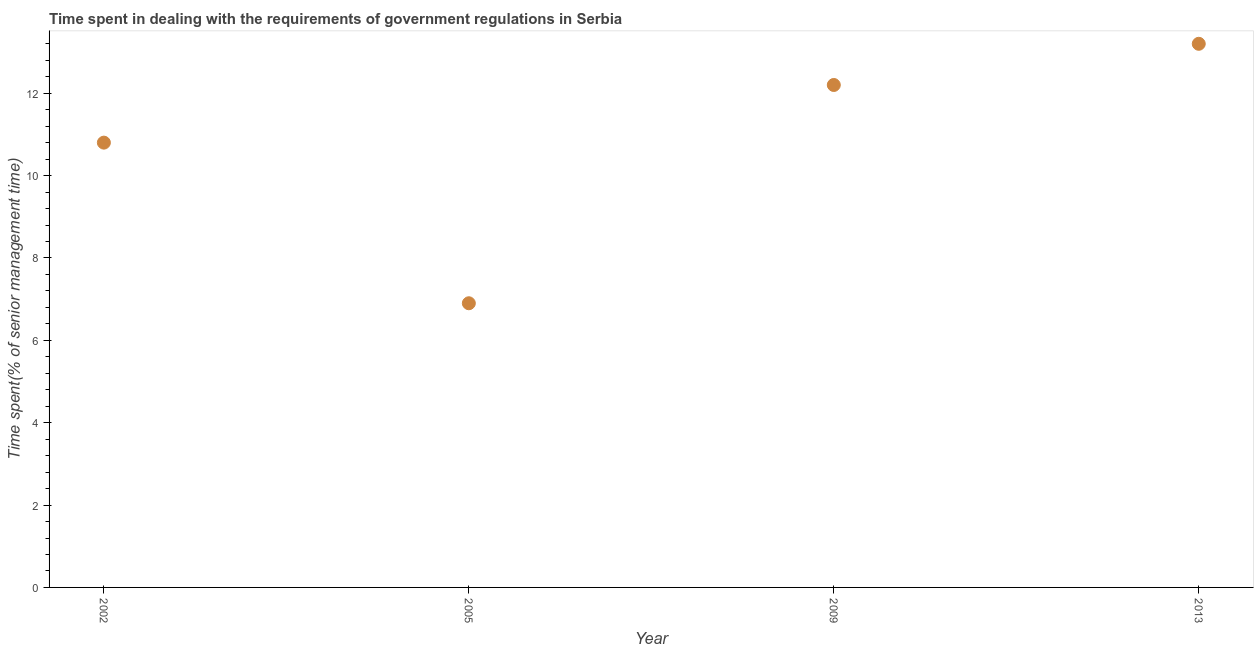What is the time spent in dealing with government regulations in 2005?
Provide a succinct answer. 6.9. Across all years, what is the maximum time spent in dealing with government regulations?
Your answer should be compact. 13.2. Across all years, what is the minimum time spent in dealing with government regulations?
Your answer should be very brief. 6.9. What is the sum of the time spent in dealing with government regulations?
Your response must be concise. 43.1. What is the difference between the time spent in dealing with government regulations in 2009 and 2013?
Your answer should be very brief. -1. What is the average time spent in dealing with government regulations per year?
Make the answer very short. 10.78. In how many years, is the time spent in dealing with government regulations greater than 5.6 %?
Provide a short and direct response. 4. What is the ratio of the time spent in dealing with government regulations in 2005 to that in 2009?
Offer a very short reply. 0.57. Is the time spent in dealing with government regulations in 2009 less than that in 2013?
Offer a terse response. Yes. Is the sum of the time spent in dealing with government regulations in 2002 and 2005 greater than the maximum time spent in dealing with government regulations across all years?
Give a very brief answer. Yes. What is the difference between the highest and the lowest time spent in dealing with government regulations?
Make the answer very short. 6.3. Does the time spent in dealing with government regulations monotonically increase over the years?
Your answer should be compact. No. How many dotlines are there?
Give a very brief answer. 1. What is the difference between two consecutive major ticks on the Y-axis?
Your answer should be compact. 2. Are the values on the major ticks of Y-axis written in scientific E-notation?
Your answer should be compact. No. Does the graph contain any zero values?
Give a very brief answer. No. Does the graph contain grids?
Ensure brevity in your answer.  No. What is the title of the graph?
Offer a terse response. Time spent in dealing with the requirements of government regulations in Serbia. What is the label or title of the Y-axis?
Your answer should be compact. Time spent(% of senior management time). What is the Time spent(% of senior management time) in 2002?
Provide a short and direct response. 10.8. What is the difference between the Time spent(% of senior management time) in 2009 and 2013?
Your response must be concise. -1. What is the ratio of the Time spent(% of senior management time) in 2002 to that in 2005?
Give a very brief answer. 1.56. What is the ratio of the Time spent(% of senior management time) in 2002 to that in 2009?
Your answer should be compact. 0.89. What is the ratio of the Time spent(% of senior management time) in 2002 to that in 2013?
Your response must be concise. 0.82. What is the ratio of the Time spent(% of senior management time) in 2005 to that in 2009?
Offer a very short reply. 0.57. What is the ratio of the Time spent(% of senior management time) in 2005 to that in 2013?
Give a very brief answer. 0.52. What is the ratio of the Time spent(% of senior management time) in 2009 to that in 2013?
Give a very brief answer. 0.92. 